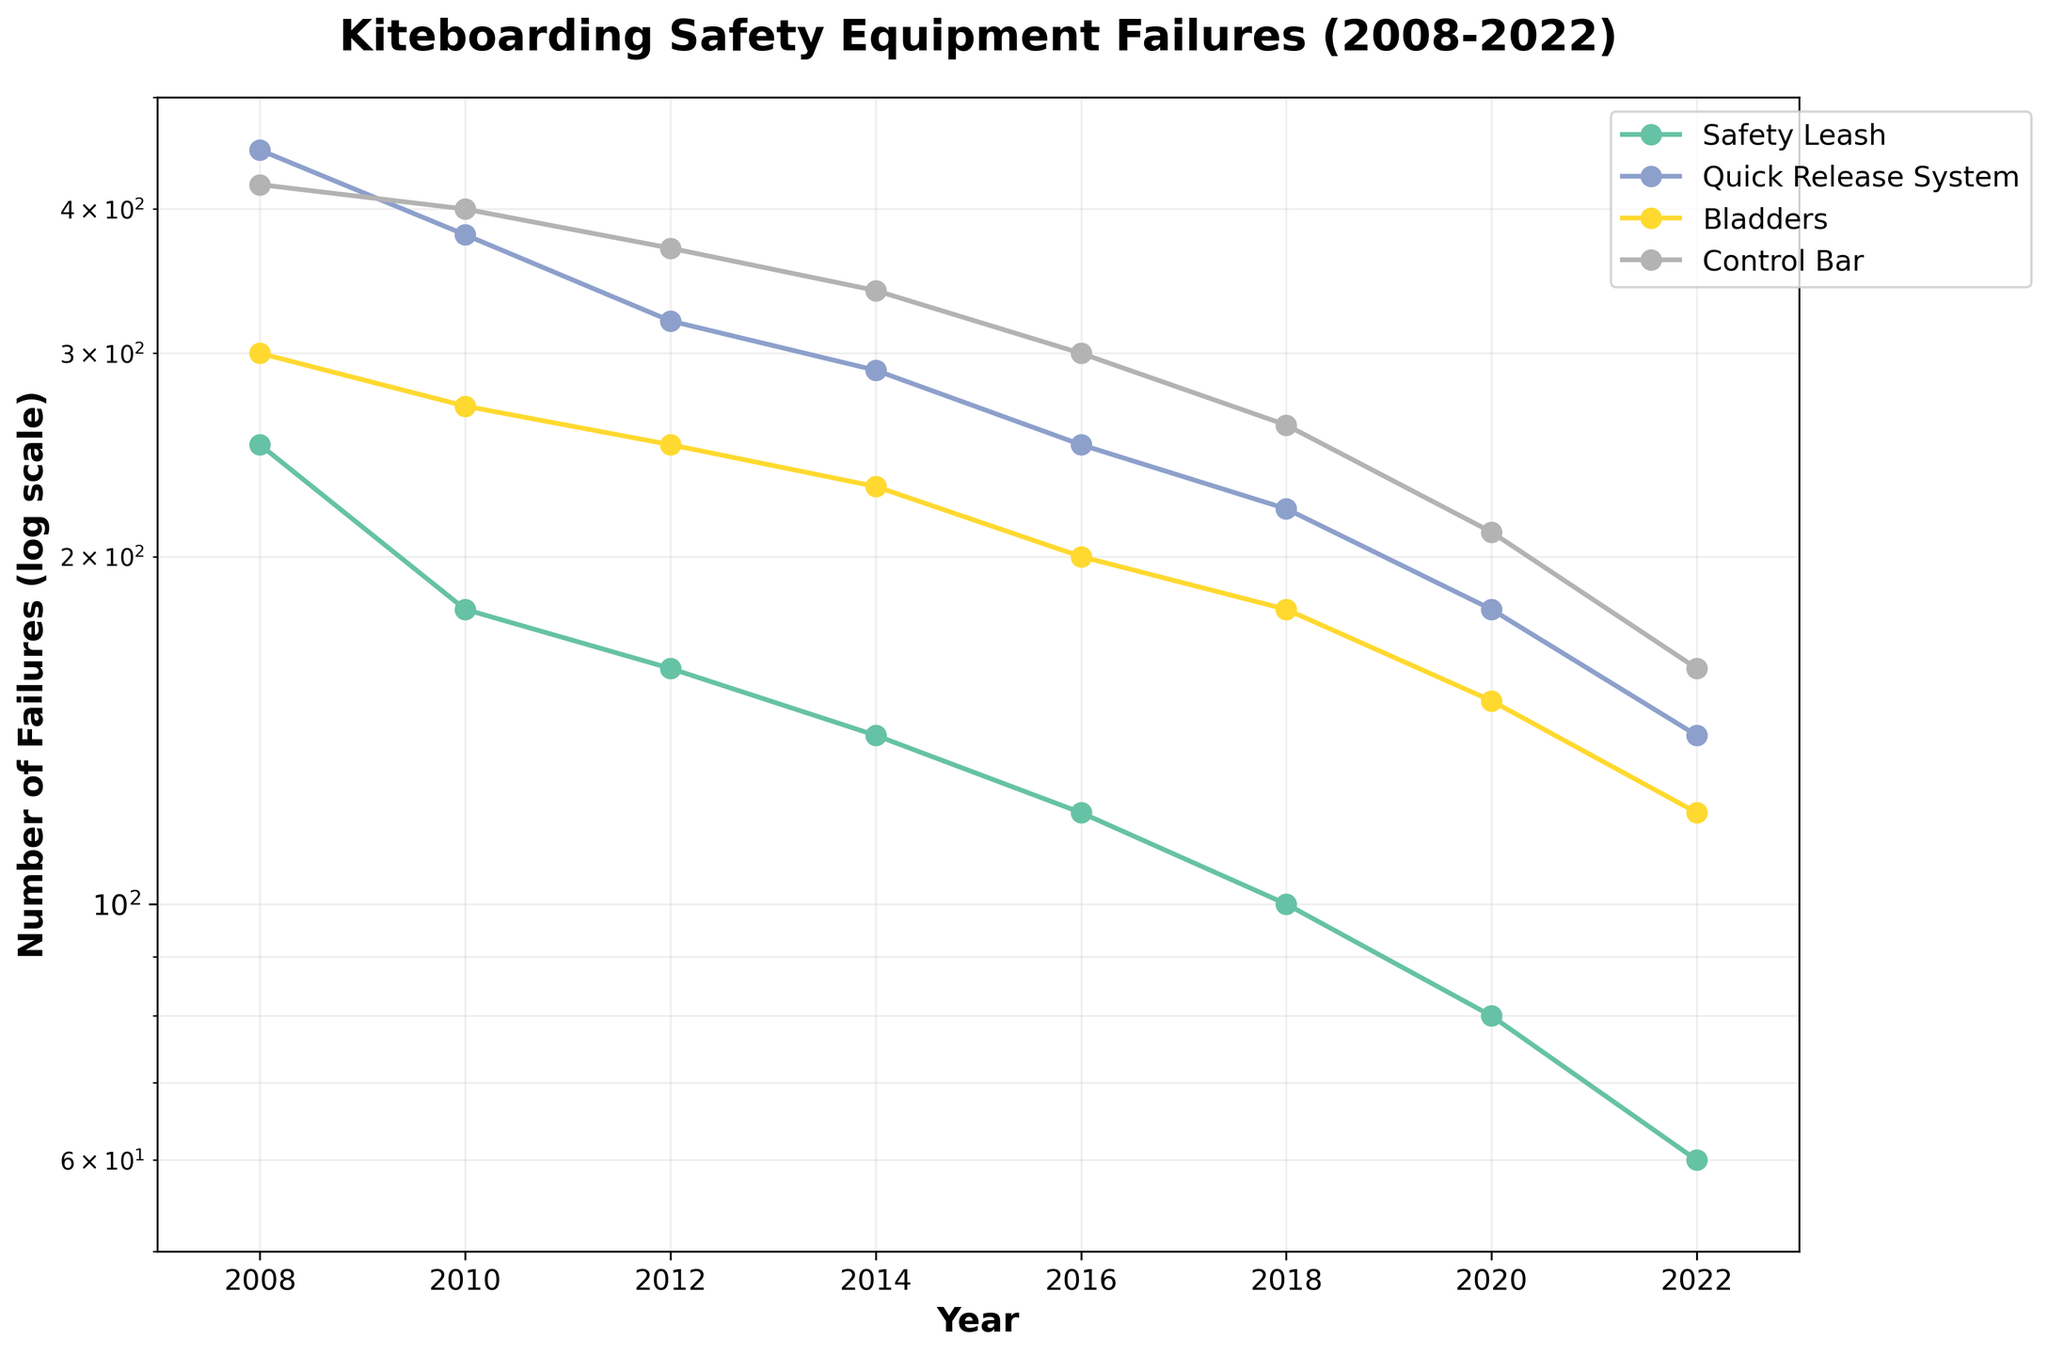What's the title of the figure? The title is usually displayed at the top of the figure. Here, it clearly states the content of the plot.
Answer: Kiteboarding Safety Equipment Failures (2008-2022) How many different equipment components are shown in the figure? By looking at the legend and the different lines, we can identify the distinct components plotted.
Answer: 4 Which component had the highest number of failures in 2008? To find this, we check the y-values for different components in 2008. The Quick Release System has the highest value.
Answer: Quick Release System What trend do you observe for the Safety Leash failures over the years? Observing the Safety Leash line, we see that the number of failures decreases consistently from 2008 to 2022.
Answer: Decreasing Which two components had an equal number of failures in any given year? By comparing the data points across the years, we notice that in 2014, Safety Leash and Control Bar had the same number of failures.
Answer: Safety Leash and Control Bar in 2014 What is the rough percentage decrease in Quick Release System failures from 2008 to 2022? The failures dropped from 450 in 2008 to 140 in 2022. The decrease is calculated as ((450-140)/450)*100.
Answer: Approximately 68.89% In which year did the number of Control Bar failures drop below 300? Checking the plot for Control Bar, it dropped below 300 in the year 2016.
Answer: 2016 By how much did the failures of Bladders decrease from 2010 to 2022? For Bladders, the failures decreased from 270 in 2010 to 120 in 2022. The difference is 270 - 120.
Answer: 150 Which component saw the least reduction in failures from 2008 to 2022? Comparing the reductions, the Safety Leash decreased from 250 to 60, Quick Release System from 450 to 140, Bladders from 300 to 120, and Control Bar from 420 to 160. The smallest reduction is in Bladders.
Answer: Bladders What does the y-axis scale indicate about the kind of changes in the number of failures? The y-axis uses a log scale, which means it shows multiplicative changes, making it easier to see proportional decreases over time.
Answer: Multiplicative changes 